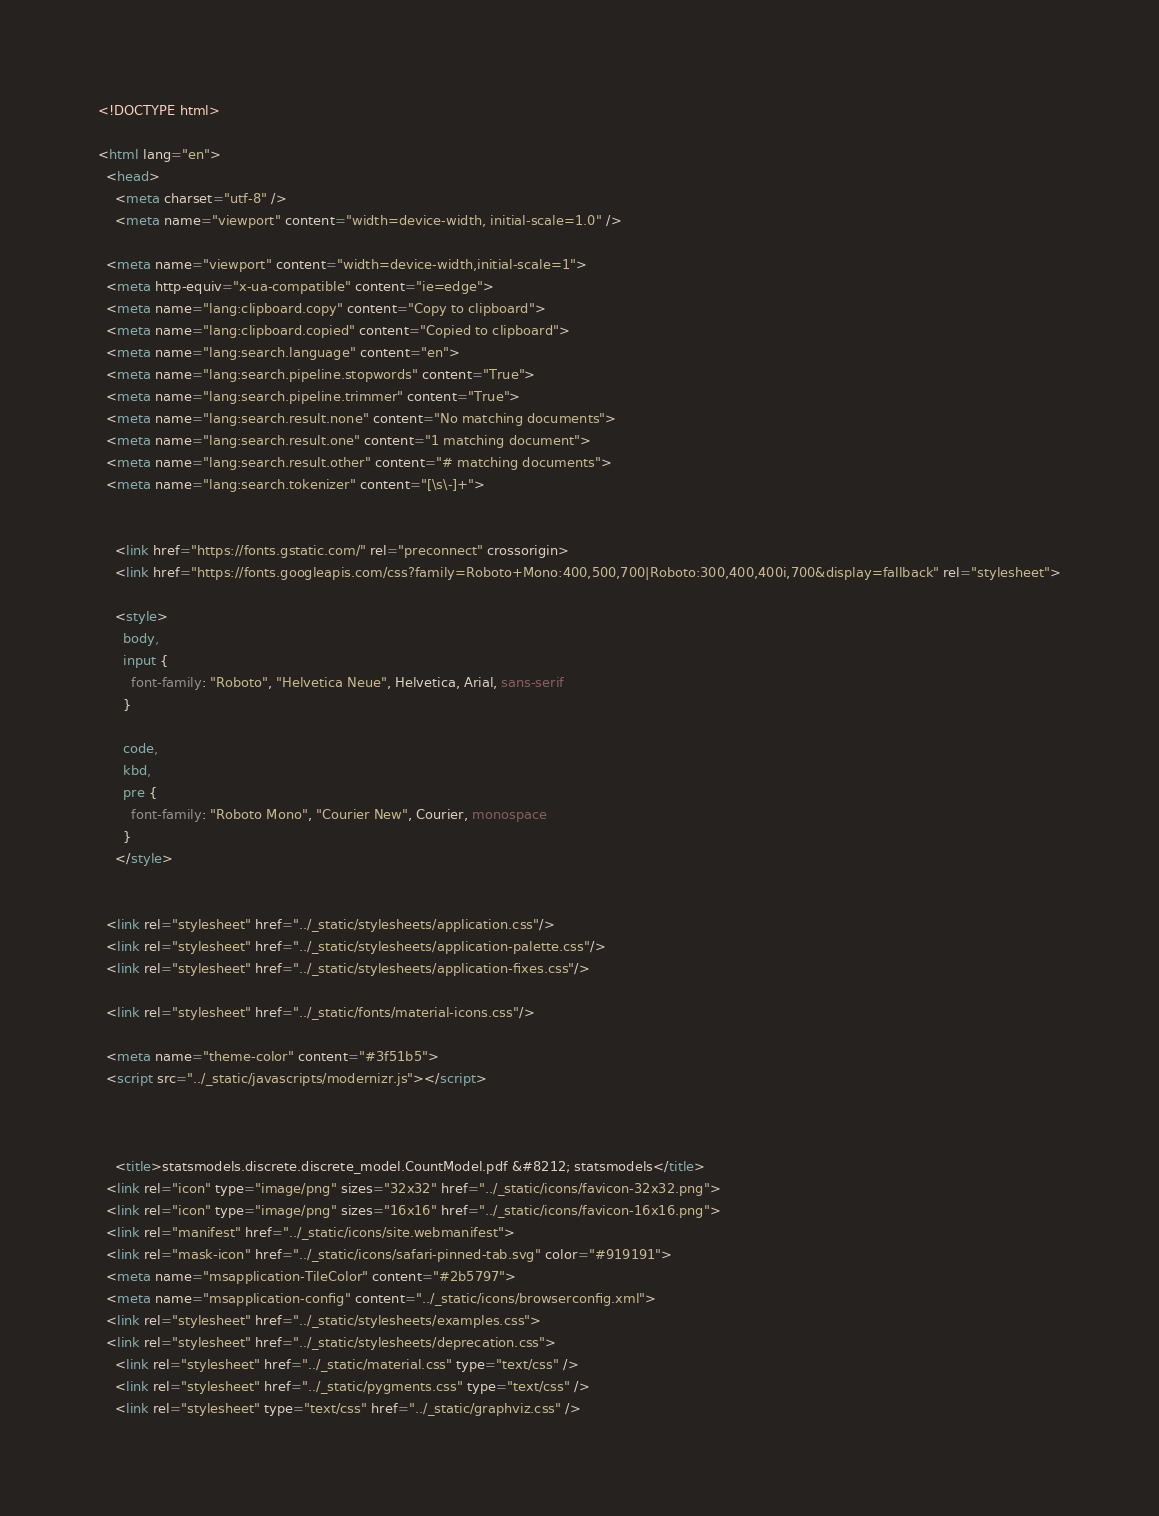Convert code to text. <code><loc_0><loc_0><loc_500><loc_500><_HTML_>

<!DOCTYPE html>

<html lang="en">
  <head>
    <meta charset="utf-8" />
    <meta name="viewport" content="width=device-width, initial-scale=1.0" />
  
  <meta name="viewport" content="width=device-width,initial-scale=1">
  <meta http-equiv="x-ua-compatible" content="ie=edge">
  <meta name="lang:clipboard.copy" content="Copy to clipboard">
  <meta name="lang:clipboard.copied" content="Copied to clipboard">
  <meta name="lang:search.language" content="en">
  <meta name="lang:search.pipeline.stopwords" content="True">
  <meta name="lang:search.pipeline.trimmer" content="True">
  <meta name="lang:search.result.none" content="No matching documents">
  <meta name="lang:search.result.one" content="1 matching document">
  <meta name="lang:search.result.other" content="# matching documents">
  <meta name="lang:search.tokenizer" content="[\s\-]+">

  
    <link href="https://fonts.gstatic.com/" rel="preconnect" crossorigin>
    <link href="https://fonts.googleapis.com/css?family=Roboto+Mono:400,500,700|Roboto:300,400,400i,700&display=fallback" rel="stylesheet">

    <style>
      body,
      input {
        font-family: "Roboto", "Helvetica Neue", Helvetica, Arial, sans-serif
      }

      code,
      kbd,
      pre {
        font-family: "Roboto Mono", "Courier New", Courier, monospace
      }
    </style>
  

  <link rel="stylesheet" href="../_static/stylesheets/application.css"/>
  <link rel="stylesheet" href="../_static/stylesheets/application-palette.css"/>
  <link rel="stylesheet" href="../_static/stylesheets/application-fixes.css"/>
  
  <link rel="stylesheet" href="../_static/fonts/material-icons.css"/>
  
  <meta name="theme-color" content="#3f51b5">
  <script src="../_static/javascripts/modernizr.js"></script>
  
  
  
    <title>statsmodels.discrete.discrete_model.CountModel.pdf &#8212; statsmodels</title>
  <link rel="icon" type="image/png" sizes="32x32" href="../_static/icons/favicon-32x32.png">
  <link rel="icon" type="image/png" sizes="16x16" href="../_static/icons/favicon-16x16.png">
  <link rel="manifest" href="../_static/icons/site.webmanifest">
  <link rel="mask-icon" href="../_static/icons/safari-pinned-tab.svg" color="#919191">
  <meta name="msapplication-TileColor" content="#2b5797">
  <meta name="msapplication-config" content="../_static/icons/browserconfig.xml">
  <link rel="stylesheet" href="../_static/stylesheets/examples.css">
  <link rel="stylesheet" href="../_static/stylesheets/deprecation.css">
    <link rel="stylesheet" href="../_static/material.css" type="text/css" />
    <link rel="stylesheet" href="../_static/pygments.css" type="text/css" />
    <link rel="stylesheet" type="text/css" href="../_static/graphviz.css" /></code> 